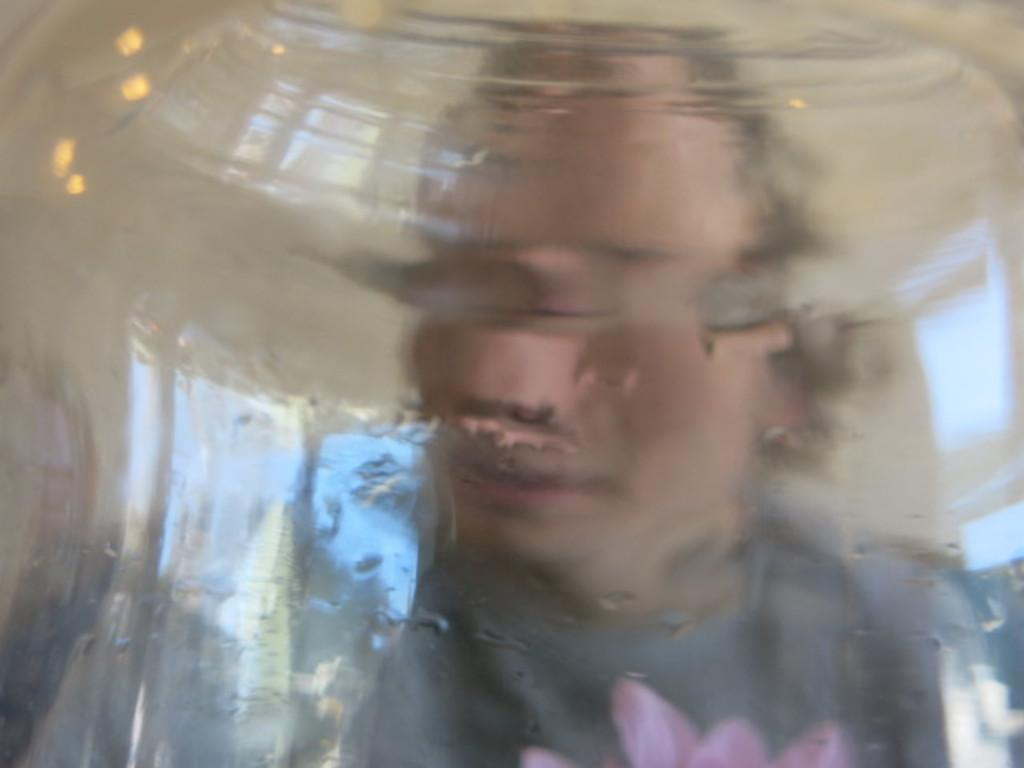What is present in the image? There is a person in the image. Can you describe the quality of the image? The image is blurred. What is the person's profession as a writer in the image? There is no information about the person's profession or any writing activity in the image. 